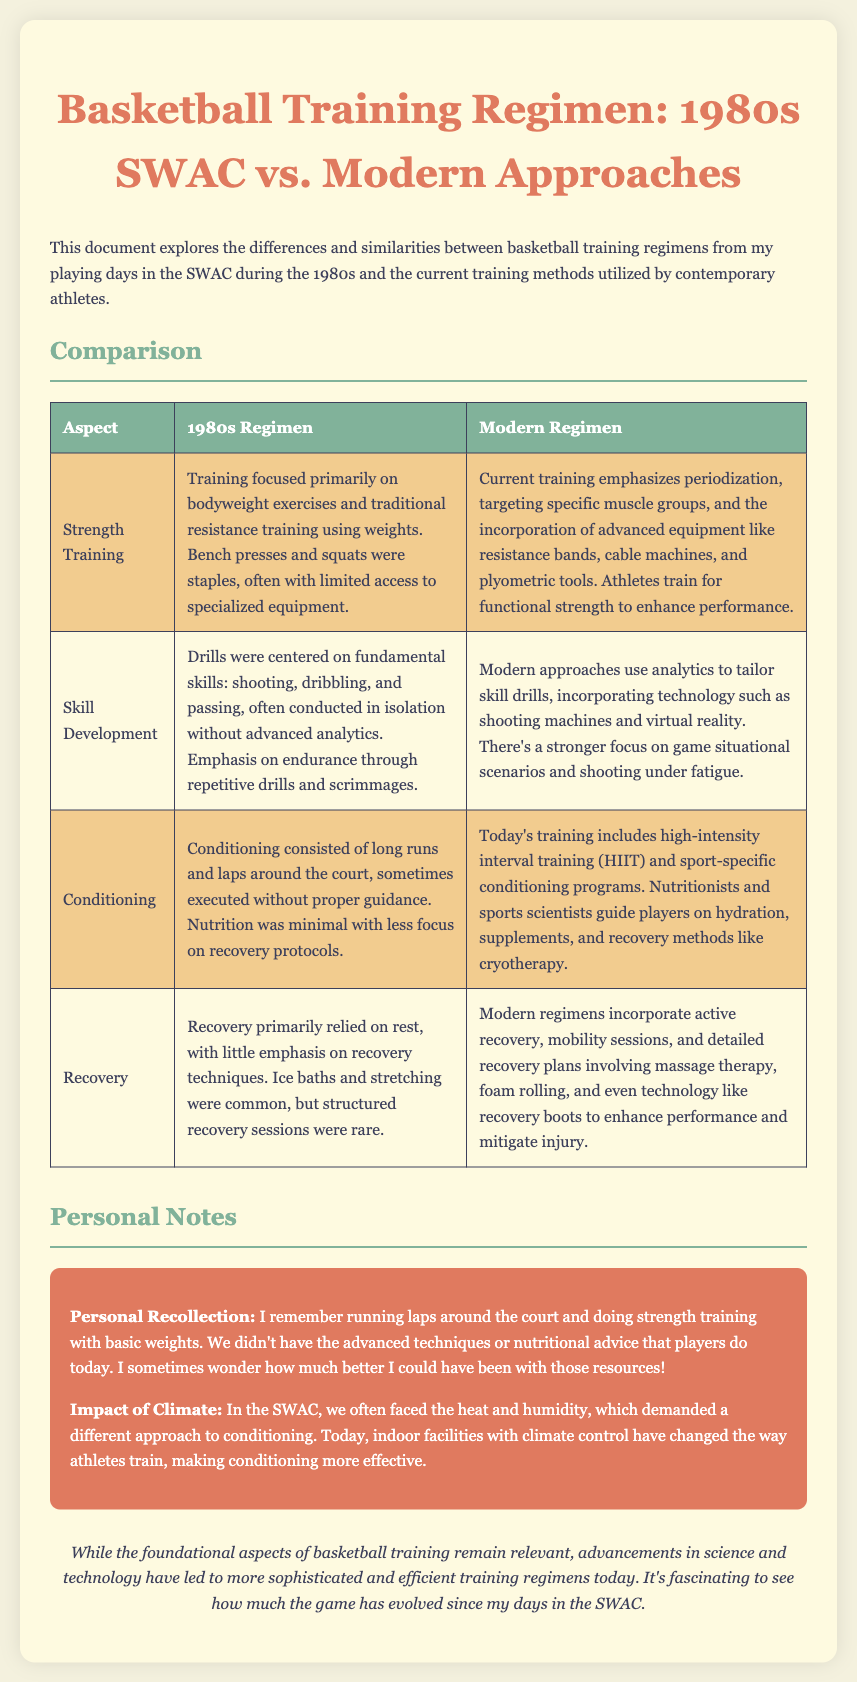What were the primary exercises in the 1980s regimen? The 1980s regimen focused primarily on bodyweight exercises and traditional resistance training using weights, such as bench presses and squats.
Answer: bodyweight exercises and traditional resistance training What aspect of skill development was emphasized in the 1980s? In the 1980s, drills centered on fundamental skills like shooting, dribbling, and passing, conducted in isolation.
Answer: fundamental skills What type of conditioning was used in the 1980s? Conditioning in the 1980s consisted of long runs and laps around the court, sometimes executed without proper guidance.
Answer: long runs and laps Who guided players on hydration and nutrition in modern training? In modern training, nutritionists and sports scientists guide players on hydration and nutrition.
Answer: nutritionists and sports scientists What recovery method was common in the 1980s? Recovery in the 1980s primarily relied on rest, with common methods including ice baths and stretching.
Answer: ice baths and stretching How has climate control impacted modern training methods? Modern training methods benefit from indoor facilities with climate control, changing how athletes train and making conditioning more effective.
Answer: indoor facilities with climate control What was a significant limitation in the 1980s training compared to today? A significant limitation in the 1980s training was the lack of advanced techniques and nutritional advice.
Answer: lack of advanced techniques and nutritional advice What was a common recovery technique mentioned for modern regimens? Modern regimens incorporate active recovery and detailed recovery plans involving massage therapy and foam rolling.
Answer: active recovery and detailed recovery plans 